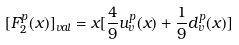<formula> <loc_0><loc_0><loc_500><loc_500>[ F _ { 2 } ^ { p } ( x ) ] _ { v a l } = x [ { \frac { 4 } { 9 } } u _ { v } ^ { p } ( x ) + { \frac { 1 } { 9 } } d _ { v } ^ { p } ( x ) ]</formula> 